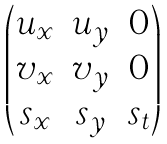<formula> <loc_0><loc_0><loc_500><loc_500>\begin{pmatrix} u _ { x } & u _ { y } & 0 \\ v _ { x } & v _ { y } & 0 \\ s _ { x } & s _ { y } & s _ { t } \end{pmatrix}</formula> 